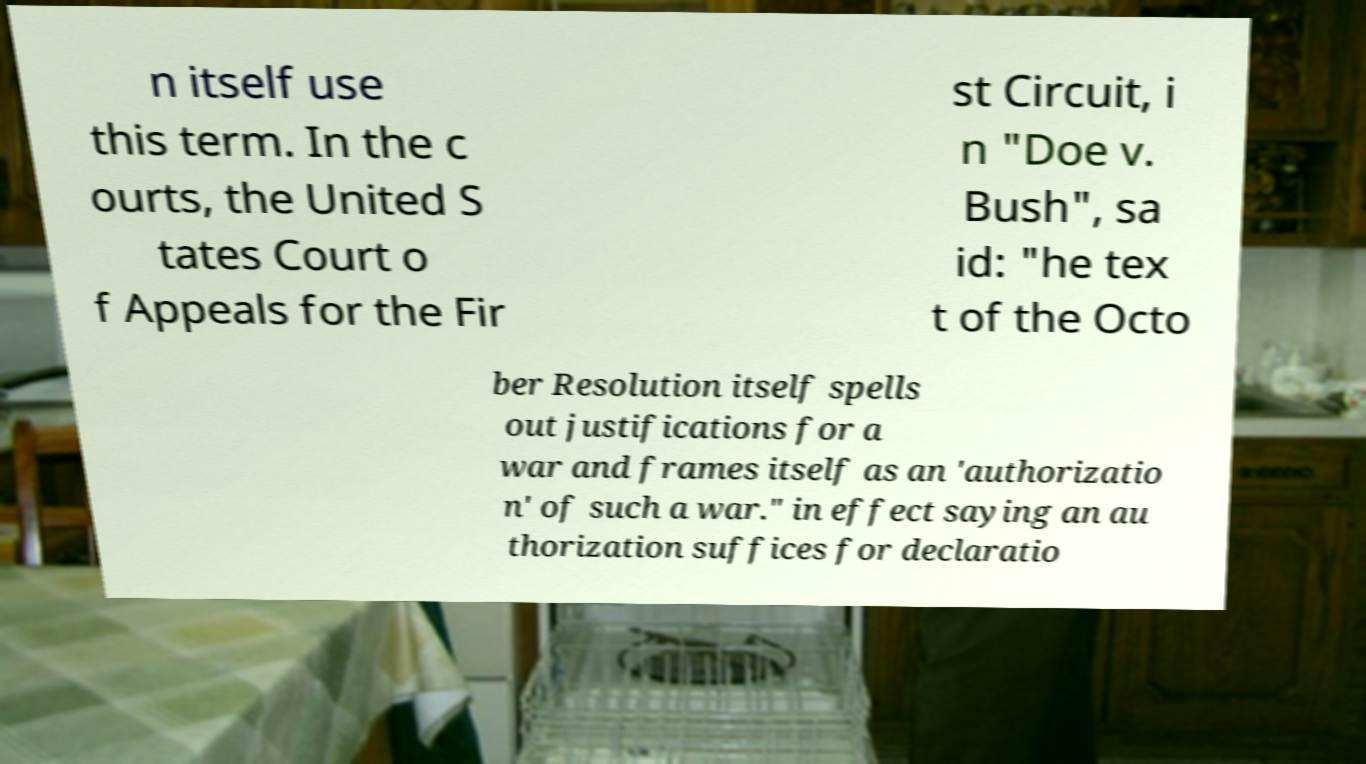There's text embedded in this image that I need extracted. Can you transcribe it verbatim? n itself use this term. In the c ourts, the United S tates Court o f Appeals for the Fir st Circuit, i n "Doe v. Bush", sa id: "he tex t of the Octo ber Resolution itself spells out justifications for a war and frames itself as an 'authorizatio n' of such a war." in effect saying an au thorization suffices for declaratio 